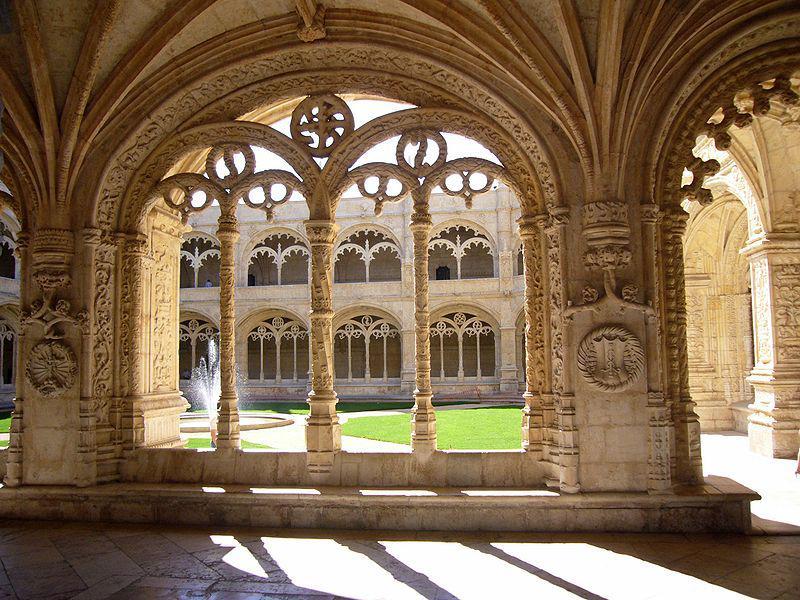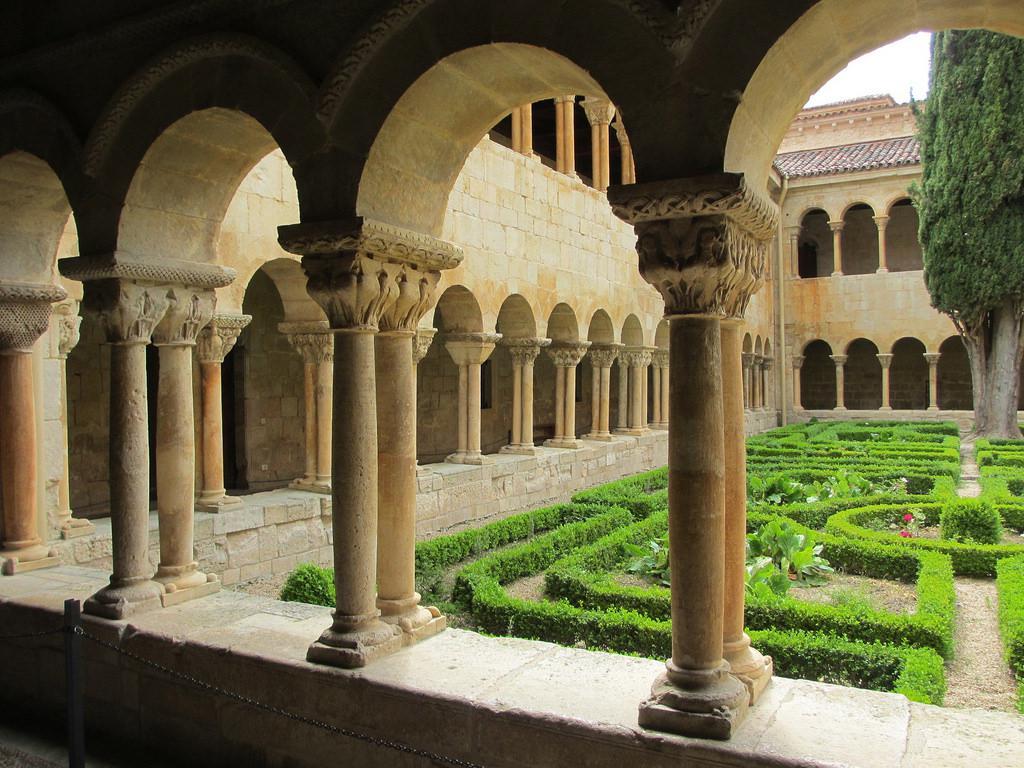The first image is the image on the left, the second image is the image on the right. Considering the images on both sides, is "The right image has no more than 4 arches." valid? Answer yes or no. No. The first image is the image on the left, the second image is the image on the right. Evaluate the accuracy of this statement regarding the images: "There is no grass or other vegetation in any of the images.". Is it true? Answer yes or no. No. 